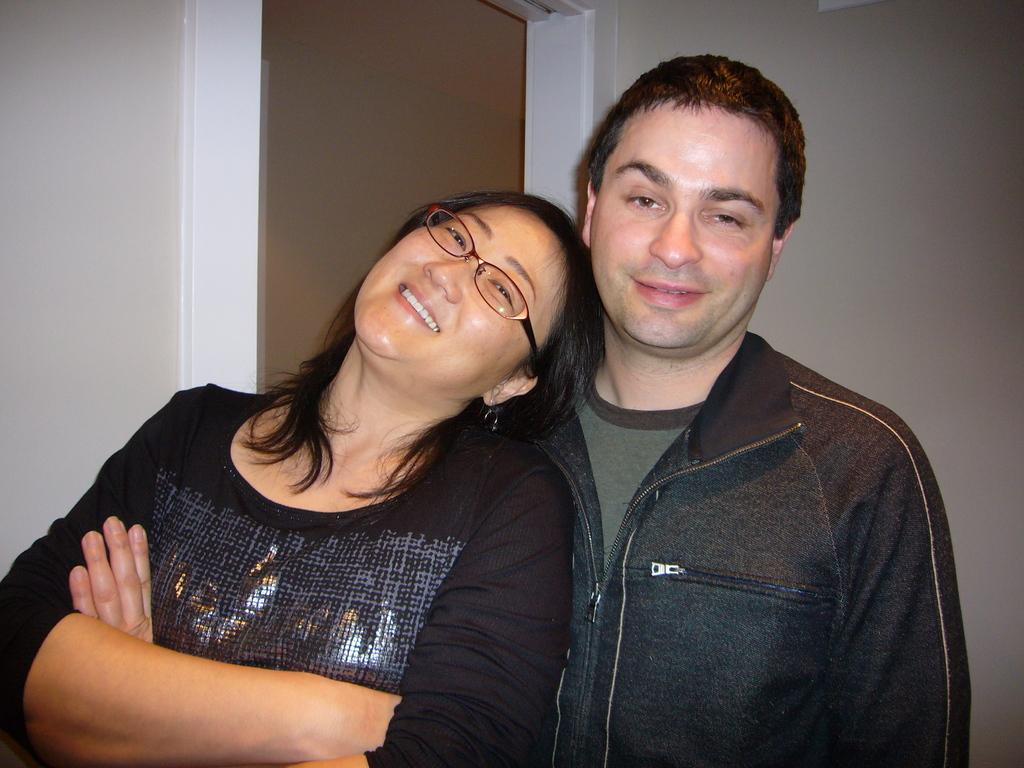How many people are in the image? There are two persons standing in the image. What are the expressions on their faces? Both persons are smiling. Can you describe any accessories worn by one of the persons? One of the persons is wearing spectacles. What can be seen in the background of the image? There is a door and a wall visible in the background of the image. What type of animal can be seen in the image? There is no animal present in the image. What view can be seen through the door in the image? The image does not show a view through the door, as it is only visible in the background. 